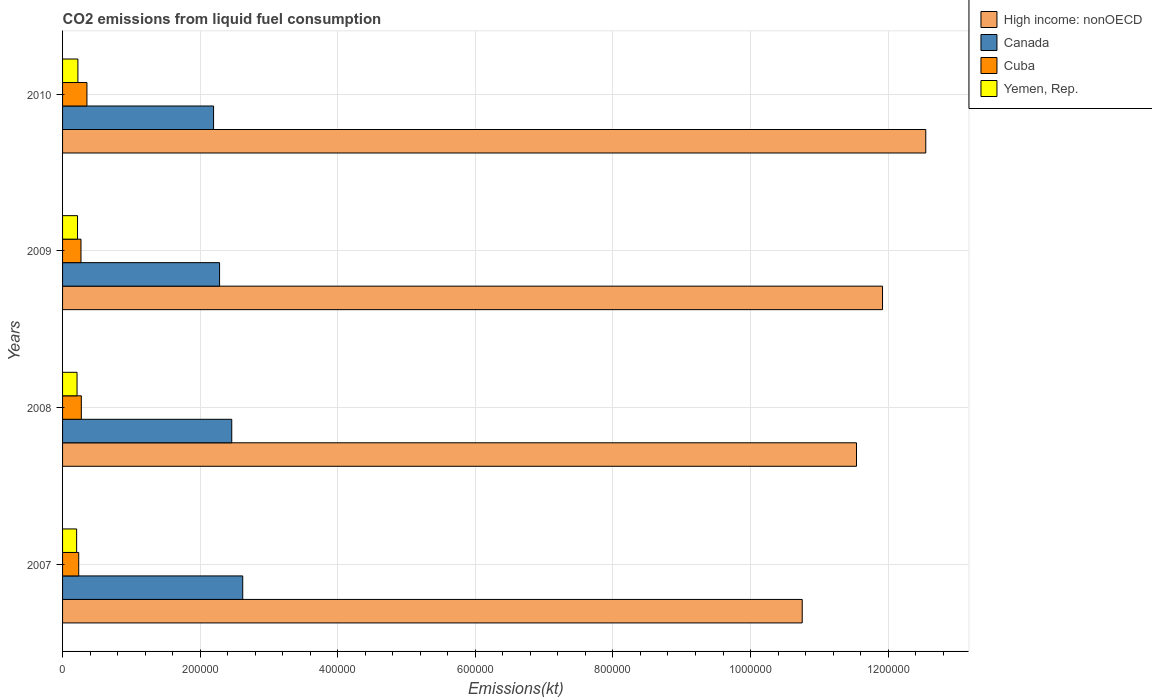How many different coloured bars are there?
Keep it short and to the point. 4. How many groups of bars are there?
Provide a succinct answer. 4. What is the label of the 2nd group of bars from the top?
Ensure brevity in your answer.  2009. In how many cases, is the number of bars for a given year not equal to the number of legend labels?
Provide a short and direct response. 0. What is the amount of CO2 emitted in Canada in 2008?
Offer a terse response. 2.46e+05. Across all years, what is the maximum amount of CO2 emitted in Cuba?
Offer a very short reply. 3.54e+04. Across all years, what is the minimum amount of CO2 emitted in High income: nonOECD?
Give a very brief answer. 1.08e+06. In which year was the amount of CO2 emitted in Canada minimum?
Offer a very short reply. 2010. What is the total amount of CO2 emitted in High income: nonOECD in the graph?
Give a very brief answer. 4.68e+06. What is the difference between the amount of CO2 emitted in High income: nonOECD in 2007 and that in 2009?
Your answer should be very brief. -1.17e+05. What is the difference between the amount of CO2 emitted in Cuba in 2010 and the amount of CO2 emitted in High income: nonOECD in 2008?
Provide a succinct answer. -1.12e+06. What is the average amount of CO2 emitted in Yemen, Rep. per year?
Your response must be concise. 2.14e+04. In the year 2010, what is the difference between the amount of CO2 emitted in High income: nonOECD and amount of CO2 emitted in Cuba?
Your answer should be very brief. 1.22e+06. In how many years, is the amount of CO2 emitted in High income: nonOECD greater than 120000 kt?
Offer a very short reply. 4. What is the ratio of the amount of CO2 emitted in Canada in 2007 to that in 2010?
Provide a succinct answer. 1.19. Is the amount of CO2 emitted in Yemen, Rep. in 2008 less than that in 2009?
Offer a terse response. Yes. What is the difference between the highest and the second highest amount of CO2 emitted in Cuba?
Ensure brevity in your answer.  8148.07. What is the difference between the highest and the lowest amount of CO2 emitted in Canada?
Give a very brief answer. 4.24e+04. Is the sum of the amount of CO2 emitted in Cuba in 2008 and 2010 greater than the maximum amount of CO2 emitted in High income: nonOECD across all years?
Give a very brief answer. No. Is it the case that in every year, the sum of the amount of CO2 emitted in Canada and amount of CO2 emitted in Yemen, Rep. is greater than the sum of amount of CO2 emitted in Cuba and amount of CO2 emitted in High income: nonOECD?
Offer a very short reply. Yes. What does the 2nd bar from the top in 2009 represents?
Your answer should be very brief. Cuba. What does the 1st bar from the bottom in 2009 represents?
Make the answer very short. High income: nonOECD. What is the title of the graph?
Provide a succinct answer. CO2 emissions from liquid fuel consumption. Does "Fiji" appear as one of the legend labels in the graph?
Offer a terse response. No. What is the label or title of the X-axis?
Your response must be concise. Emissions(kt). What is the Emissions(kt) in High income: nonOECD in 2007?
Provide a short and direct response. 1.08e+06. What is the Emissions(kt) of Canada in 2007?
Offer a terse response. 2.62e+05. What is the Emissions(kt) of Cuba in 2007?
Offer a terse response. 2.35e+04. What is the Emissions(kt) of Yemen, Rep. in 2007?
Your response must be concise. 2.04e+04. What is the Emissions(kt) of High income: nonOECD in 2008?
Offer a terse response. 1.15e+06. What is the Emissions(kt) in Canada in 2008?
Keep it short and to the point. 2.46e+05. What is the Emissions(kt) in Cuba in 2008?
Offer a terse response. 2.73e+04. What is the Emissions(kt) of Yemen, Rep. in 2008?
Provide a short and direct response. 2.10e+04. What is the Emissions(kt) in High income: nonOECD in 2009?
Provide a short and direct response. 1.19e+06. What is the Emissions(kt) of Canada in 2009?
Provide a short and direct response. 2.28e+05. What is the Emissions(kt) of Cuba in 2009?
Make the answer very short. 2.68e+04. What is the Emissions(kt) in Yemen, Rep. in 2009?
Offer a very short reply. 2.18e+04. What is the Emissions(kt) of High income: nonOECD in 2010?
Offer a very short reply. 1.25e+06. What is the Emissions(kt) in Canada in 2010?
Offer a terse response. 2.20e+05. What is the Emissions(kt) of Cuba in 2010?
Give a very brief answer. 3.54e+04. What is the Emissions(kt) in Yemen, Rep. in 2010?
Your response must be concise. 2.23e+04. Across all years, what is the maximum Emissions(kt) of High income: nonOECD?
Provide a succinct answer. 1.25e+06. Across all years, what is the maximum Emissions(kt) in Canada?
Your response must be concise. 2.62e+05. Across all years, what is the maximum Emissions(kt) of Cuba?
Ensure brevity in your answer.  3.54e+04. Across all years, what is the maximum Emissions(kt) in Yemen, Rep.?
Provide a short and direct response. 2.23e+04. Across all years, what is the minimum Emissions(kt) of High income: nonOECD?
Your answer should be compact. 1.08e+06. Across all years, what is the minimum Emissions(kt) of Canada?
Provide a short and direct response. 2.20e+05. Across all years, what is the minimum Emissions(kt) of Cuba?
Your response must be concise. 2.35e+04. Across all years, what is the minimum Emissions(kt) of Yemen, Rep.?
Your response must be concise. 2.04e+04. What is the total Emissions(kt) in High income: nonOECD in the graph?
Your answer should be very brief. 4.68e+06. What is the total Emissions(kt) of Canada in the graph?
Give a very brief answer. 9.56e+05. What is the total Emissions(kt) in Cuba in the graph?
Provide a succinct answer. 1.13e+05. What is the total Emissions(kt) in Yemen, Rep. in the graph?
Your answer should be compact. 8.55e+04. What is the difference between the Emissions(kt) of High income: nonOECD in 2007 and that in 2008?
Keep it short and to the point. -7.89e+04. What is the difference between the Emissions(kt) in Canada in 2007 and that in 2008?
Provide a short and direct response. 1.60e+04. What is the difference between the Emissions(kt) of Cuba in 2007 and that in 2008?
Your response must be concise. -3788.01. What is the difference between the Emissions(kt) of Yemen, Rep. in 2007 and that in 2008?
Your answer should be compact. -608.72. What is the difference between the Emissions(kt) of High income: nonOECD in 2007 and that in 2009?
Your answer should be compact. -1.17e+05. What is the difference between the Emissions(kt) in Canada in 2007 and that in 2009?
Make the answer very short. 3.37e+04. What is the difference between the Emissions(kt) of Cuba in 2007 and that in 2009?
Give a very brief answer. -3296.63. What is the difference between the Emissions(kt) of Yemen, Rep. in 2007 and that in 2009?
Make the answer very short. -1327.45. What is the difference between the Emissions(kt) in High income: nonOECD in 2007 and that in 2010?
Offer a very short reply. -1.80e+05. What is the difference between the Emissions(kt) in Canada in 2007 and that in 2010?
Keep it short and to the point. 4.24e+04. What is the difference between the Emissions(kt) of Cuba in 2007 and that in 2010?
Offer a terse response. -1.19e+04. What is the difference between the Emissions(kt) in Yemen, Rep. in 2007 and that in 2010?
Provide a short and direct response. -1855.5. What is the difference between the Emissions(kt) of High income: nonOECD in 2008 and that in 2009?
Give a very brief answer. -3.78e+04. What is the difference between the Emissions(kt) in Canada in 2008 and that in 2009?
Your answer should be compact. 1.77e+04. What is the difference between the Emissions(kt) in Cuba in 2008 and that in 2009?
Provide a succinct answer. 491.38. What is the difference between the Emissions(kt) of Yemen, Rep. in 2008 and that in 2009?
Your response must be concise. -718.73. What is the difference between the Emissions(kt) of High income: nonOECD in 2008 and that in 2010?
Your answer should be compact. -1.01e+05. What is the difference between the Emissions(kt) of Canada in 2008 and that in 2010?
Offer a terse response. 2.64e+04. What is the difference between the Emissions(kt) of Cuba in 2008 and that in 2010?
Provide a short and direct response. -8148.07. What is the difference between the Emissions(kt) of Yemen, Rep. in 2008 and that in 2010?
Your answer should be compact. -1246.78. What is the difference between the Emissions(kt) in High income: nonOECD in 2009 and that in 2010?
Offer a terse response. -6.29e+04. What is the difference between the Emissions(kt) of Canada in 2009 and that in 2010?
Keep it short and to the point. 8709.12. What is the difference between the Emissions(kt) in Cuba in 2009 and that in 2010?
Your response must be concise. -8639.45. What is the difference between the Emissions(kt) in Yemen, Rep. in 2009 and that in 2010?
Keep it short and to the point. -528.05. What is the difference between the Emissions(kt) of High income: nonOECD in 2007 and the Emissions(kt) of Canada in 2008?
Give a very brief answer. 8.29e+05. What is the difference between the Emissions(kt) in High income: nonOECD in 2007 and the Emissions(kt) in Cuba in 2008?
Give a very brief answer. 1.05e+06. What is the difference between the Emissions(kt) of High income: nonOECD in 2007 and the Emissions(kt) of Yemen, Rep. in 2008?
Keep it short and to the point. 1.05e+06. What is the difference between the Emissions(kt) in Canada in 2007 and the Emissions(kt) in Cuba in 2008?
Your answer should be very brief. 2.35e+05. What is the difference between the Emissions(kt) of Canada in 2007 and the Emissions(kt) of Yemen, Rep. in 2008?
Offer a very short reply. 2.41e+05. What is the difference between the Emissions(kt) of Cuba in 2007 and the Emissions(kt) of Yemen, Rep. in 2008?
Keep it short and to the point. 2438.55. What is the difference between the Emissions(kt) of High income: nonOECD in 2007 and the Emissions(kt) of Canada in 2009?
Ensure brevity in your answer.  8.47e+05. What is the difference between the Emissions(kt) of High income: nonOECD in 2007 and the Emissions(kt) of Cuba in 2009?
Ensure brevity in your answer.  1.05e+06. What is the difference between the Emissions(kt) in High income: nonOECD in 2007 and the Emissions(kt) in Yemen, Rep. in 2009?
Provide a short and direct response. 1.05e+06. What is the difference between the Emissions(kt) of Canada in 2007 and the Emissions(kt) of Cuba in 2009?
Keep it short and to the point. 2.35e+05. What is the difference between the Emissions(kt) of Canada in 2007 and the Emissions(kt) of Yemen, Rep. in 2009?
Offer a very short reply. 2.40e+05. What is the difference between the Emissions(kt) of Cuba in 2007 and the Emissions(kt) of Yemen, Rep. in 2009?
Offer a very short reply. 1719.82. What is the difference between the Emissions(kt) in High income: nonOECD in 2007 and the Emissions(kt) in Canada in 2010?
Offer a terse response. 8.56e+05. What is the difference between the Emissions(kt) of High income: nonOECD in 2007 and the Emissions(kt) of Cuba in 2010?
Your answer should be compact. 1.04e+06. What is the difference between the Emissions(kt) of High income: nonOECD in 2007 and the Emissions(kt) of Yemen, Rep. in 2010?
Ensure brevity in your answer.  1.05e+06. What is the difference between the Emissions(kt) of Canada in 2007 and the Emissions(kt) of Cuba in 2010?
Offer a terse response. 2.26e+05. What is the difference between the Emissions(kt) of Canada in 2007 and the Emissions(kt) of Yemen, Rep. in 2010?
Your response must be concise. 2.40e+05. What is the difference between the Emissions(kt) in Cuba in 2007 and the Emissions(kt) in Yemen, Rep. in 2010?
Make the answer very short. 1191.78. What is the difference between the Emissions(kt) in High income: nonOECD in 2008 and the Emissions(kt) in Canada in 2009?
Provide a succinct answer. 9.26e+05. What is the difference between the Emissions(kt) of High income: nonOECD in 2008 and the Emissions(kt) of Cuba in 2009?
Ensure brevity in your answer.  1.13e+06. What is the difference between the Emissions(kt) in High income: nonOECD in 2008 and the Emissions(kt) in Yemen, Rep. in 2009?
Give a very brief answer. 1.13e+06. What is the difference between the Emissions(kt) of Canada in 2008 and the Emissions(kt) of Cuba in 2009?
Your response must be concise. 2.19e+05. What is the difference between the Emissions(kt) in Canada in 2008 and the Emissions(kt) in Yemen, Rep. in 2009?
Your answer should be very brief. 2.24e+05. What is the difference between the Emissions(kt) of Cuba in 2008 and the Emissions(kt) of Yemen, Rep. in 2009?
Give a very brief answer. 5507.83. What is the difference between the Emissions(kt) of High income: nonOECD in 2008 and the Emissions(kt) of Canada in 2010?
Provide a succinct answer. 9.35e+05. What is the difference between the Emissions(kt) of High income: nonOECD in 2008 and the Emissions(kt) of Cuba in 2010?
Your answer should be very brief. 1.12e+06. What is the difference between the Emissions(kt) in High income: nonOECD in 2008 and the Emissions(kt) in Yemen, Rep. in 2010?
Your answer should be compact. 1.13e+06. What is the difference between the Emissions(kt) in Canada in 2008 and the Emissions(kt) in Cuba in 2010?
Ensure brevity in your answer.  2.11e+05. What is the difference between the Emissions(kt) of Canada in 2008 and the Emissions(kt) of Yemen, Rep. in 2010?
Offer a terse response. 2.24e+05. What is the difference between the Emissions(kt) in Cuba in 2008 and the Emissions(kt) in Yemen, Rep. in 2010?
Your response must be concise. 4979.79. What is the difference between the Emissions(kt) of High income: nonOECD in 2009 and the Emissions(kt) of Canada in 2010?
Your answer should be compact. 9.72e+05. What is the difference between the Emissions(kt) in High income: nonOECD in 2009 and the Emissions(kt) in Cuba in 2010?
Your response must be concise. 1.16e+06. What is the difference between the Emissions(kt) of High income: nonOECD in 2009 and the Emissions(kt) of Yemen, Rep. in 2010?
Give a very brief answer. 1.17e+06. What is the difference between the Emissions(kt) of Canada in 2009 and the Emissions(kt) of Cuba in 2010?
Your response must be concise. 1.93e+05. What is the difference between the Emissions(kt) of Canada in 2009 and the Emissions(kt) of Yemen, Rep. in 2010?
Provide a succinct answer. 2.06e+05. What is the difference between the Emissions(kt) of Cuba in 2009 and the Emissions(kt) of Yemen, Rep. in 2010?
Your answer should be very brief. 4488.41. What is the average Emissions(kt) of High income: nonOECD per year?
Ensure brevity in your answer.  1.17e+06. What is the average Emissions(kt) in Canada per year?
Keep it short and to the point. 2.39e+05. What is the average Emissions(kt) in Cuba per year?
Provide a short and direct response. 2.82e+04. What is the average Emissions(kt) in Yemen, Rep. per year?
Provide a short and direct response. 2.14e+04. In the year 2007, what is the difference between the Emissions(kt) of High income: nonOECD and Emissions(kt) of Canada?
Your answer should be compact. 8.13e+05. In the year 2007, what is the difference between the Emissions(kt) in High income: nonOECD and Emissions(kt) in Cuba?
Provide a succinct answer. 1.05e+06. In the year 2007, what is the difference between the Emissions(kt) in High income: nonOECD and Emissions(kt) in Yemen, Rep.?
Offer a terse response. 1.05e+06. In the year 2007, what is the difference between the Emissions(kt) in Canada and Emissions(kt) in Cuba?
Provide a short and direct response. 2.38e+05. In the year 2007, what is the difference between the Emissions(kt) of Canada and Emissions(kt) of Yemen, Rep.?
Offer a terse response. 2.41e+05. In the year 2007, what is the difference between the Emissions(kt) of Cuba and Emissions(kt) of Yemen, Rep.?
Offer a very short reply. 3047.28. In the year 2008, what is the difference between the Emissions(kt) in High income: nonOECD and Emissions(kt) in Canada?
Your response must be concise. 9.08e+05. In the year 2008, what is the difference between the Emissions(kt) of High income: nonOECD and Emissions(kt) of Cuba?
Ensure brevity in your answer.  1.13e+06. In the year 2008, what is the difference between the Emissions(kt) of High income: nonOECD and Emissions(kt) of Yemen, Rep.?
Provide a succinct answer. 1.13e+06. In the year 2008, what is the difference between the Emissions(kt) of Canada and Emissions(kt) of Cuba?
Ensure brevity in your answer.  2.19e+05. In the year 2008, what is the difference between the Emissions(kt) in Canada and Emissions(kt) in Yemen, Rep.?
Keep it short and to the point. 2.25e+05. In the year 2008, what is the difference between the Emissions(kt) in Cuba and Emissions(kt) in Yemen, Rep.?
Your answer should be very brief. 6226.57. In the year 2009, what is the difference between the Emissions(kt) of High income: nonOECD and Emissions(kt) of Canada?
Your answer should be very brief. 9.64e+05. In the year 2009, what is the difference between the Emissions(kt) in High income: nonOECD and Emissions(kt) in Cuba?
Your response must be concise. 1.17e+06. In the year 2009, what is the difference between the Emissions(kt) of High income: nonOECD and Emissions(kt) of Yemen, Rep.?
Offer a very short reply. 1.17e+06. In the year 2009, what is the difference between the Emissions(kt) in Canada and Emissions(kt) in Cuba?
Provide a succinct answer. 2.01e+05. In the year 2009, what is the difference between the Emissions(kt) of Canada and Emissions(kt) of Yemen, Rep.?
Provide a short and direct response. 2.06e+05. In the year 2009, what is the difference between the Emissions(kt) in Cuba and Emissions(kt) in Yemen, Rep.?
Ensure brevity in your answer.  5016.46. In the year 2010, what is the difference between the Emissions(kt) of High income: nonOECD and Emissions(kt) of Canada?
Ensure brevity in your answer.  1.04e+06. In the year 2010, what is the difference between the Emissions(kt) of High income: nonOECD and Emissions(kt) of Cuba?
Your answer should be very brief. 1.22e+06. In the year 2010, what is the difference between the Emissions(kt) in High income: nonOECD and Emissions(kt) in Yemen, Rep.?
Keep it short and to the point. 1.23e+06. In the year 2010, what is the difference between the Emissions(kt) of Canada and Emissions(kt) of Cuba?
Keep it short and to the point. 1.84e+05. In the year 2010, what is the difference between the Emissions(kt) of Canada and Emissions(kt) of Yemen, Rep.?
Provide a succinct answer. 1.97e+05. In the year 2010, what is the difference between the Emissions(kt) in Cuba and Emissions(kt) in Yemen, Rep.?
Keep it short and to the point. 1.31e+04. What is the ratio of the Emissions(kt) of High income: nonOECD in 2007 to that in 2008?
Offer a terse response. 0.93. What is the ratio of the Emissions(kt) of Canada in 2007 to that in 2008?
Provide a short and direct response. 1.06. What is the ratio of the Emissions(kt) in Cuba in 2007 to that in 2008?
Provide a short and direct response. 0.86. What is the ratio of the Emissions(kt) of Yemen, Rep. in 2007 to that in 2008?
Your answer should be compact. 0.97. What is the ratio of the Emissions(kt) in High income: nonOECD in 2007 to that in 2009?
Provide a succinct answer. 0.9. What is the ratio of the Emissions(kt) of Canada in 2007 to that in 2009?
Make the answer very short. 1.15. What is the ratio of the Emissions(kt) in Cuba in 2007 to that in 2009?
Your answer should be compact. 0.88. What is the ratio of the Emissions(kt) in Yemen, Rep. in 2007 to that in 2009?
Keep it short and to the point. 0.94. What is the ratio of the Emissions(kt) in High income: nonOECD in 2007 to that in 2010?
Keep it short and to the point. 0.86. What is the ratio of the Emissions(kt) in Canada in 2007 to that in 2010?
Your response must be concise. 1.19. What is the ratio of the Emissions(kt) in Cuba in 2007 to that in 2010?
Offer a terse response. 0.66. What is the ratio of the Emissions(kt) in Yemen, Rep. in 2007 to that in 2010?
Your response must be concise. 0.92. What is the ratio of the Emissions(kt) of High income: nonOECD in 2008 to that in 2009?
Give a very brief answer. 0.97. What is the ratio of the Emissions(kt) in Canada in 2008 to that in 2009?
Make the answer very short. 1.08. What is the ratio of the Emissions(kt) of Cuba in 2008 to that in 2009?
Offer a terse response. 1.02. What is the ratio of the Emissions(kt) in High income: nonOECD in 2008 to that in 2010?
Your answer should be compact. 0.92. What is the ratio of the Emissions(kt) of Canada in 2008 to that in 2010?
Keep it short and to the point. 1.12. What is the ratio of the Emissions(kt) in Cuba in 2008 to that in 2010?
Give a very brief answer. 0.77. What is the ratio of the Emissions(kt) in Yemen, Rep. in 2008 to that in 2010?
Your answer should be compact. 0.94. What is the ratio of the Emissions(kt) in High income: nonOECD in 2009 to that in 2010?
Keep it short and to the point. 0.95. What is the ratio of the Emissions(kt) of Canada in 2009 to that in 2010?
Make the answer very short. 1.04. What is the ratio of the Emissions(kt) in Cuba in 2009 to that in 2010?
Offer a terse response. 0.76. What is the ratio of the Emissions(kt) of Yemen, Rep. in 2009 to that in 2010?
Offer a terse response. 0.98. What is the difference between the highest and the second highest Emissions(kt) in High income: nonOECD?
Make the answer very short. 6.29e+04. What is the difference between the highest and the second highest Emissions(kt) of Canada?
Your answer should be very brief. 1.60e+04. What is the difference between the highest and the second highest Emissions(kt) in Cuba?
Your answer should be compact. 8148.07. What is the difference between the highest and the second highest Emissions(kt) of Yemen, Rep.?
Your answer should be compact. 528.05. What is the difference between the highest and the lowest Emissions(kt) in High income: nonOECD?
Ensure brevity in your answer.  1.80e+05. What is the difference between the highest and the lowest Emissions(kt) of Canada?
Offer a terse response. 4.24e+04. What is the difference between the highest and the lowest Emissions(kt) of Cuba?
Offer a terse response. 1.19e+04. What is the difference between the highest and the lowest Emissions(kt) in Yemen, Rep.?
Your answer should be compact. 1855.5. 